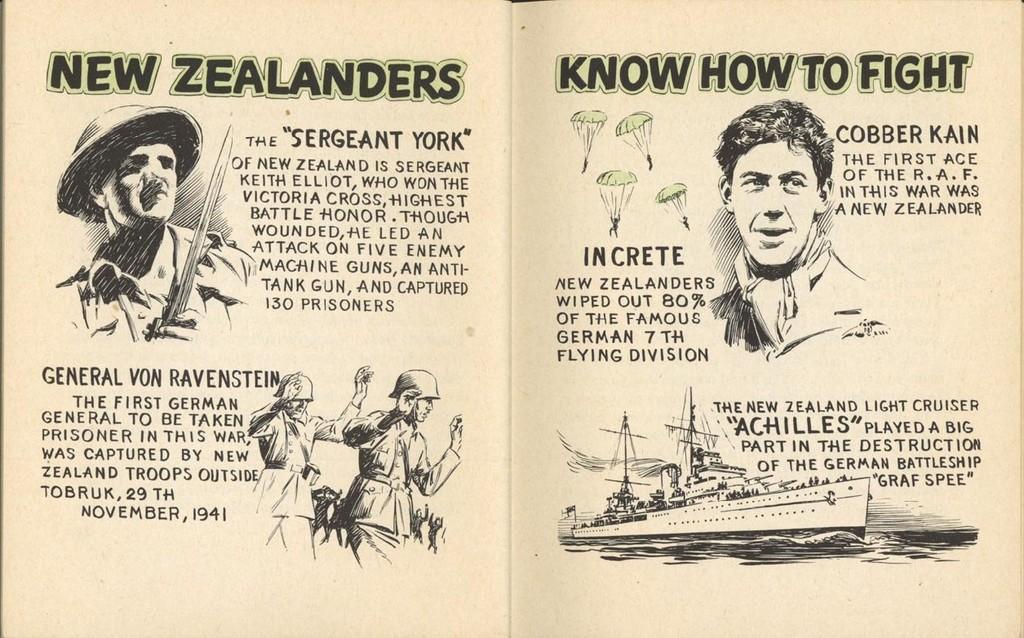How would you summarize this image in a sentence or two? This image is a picture of a book, in this picture there is text and images of a few persons. 